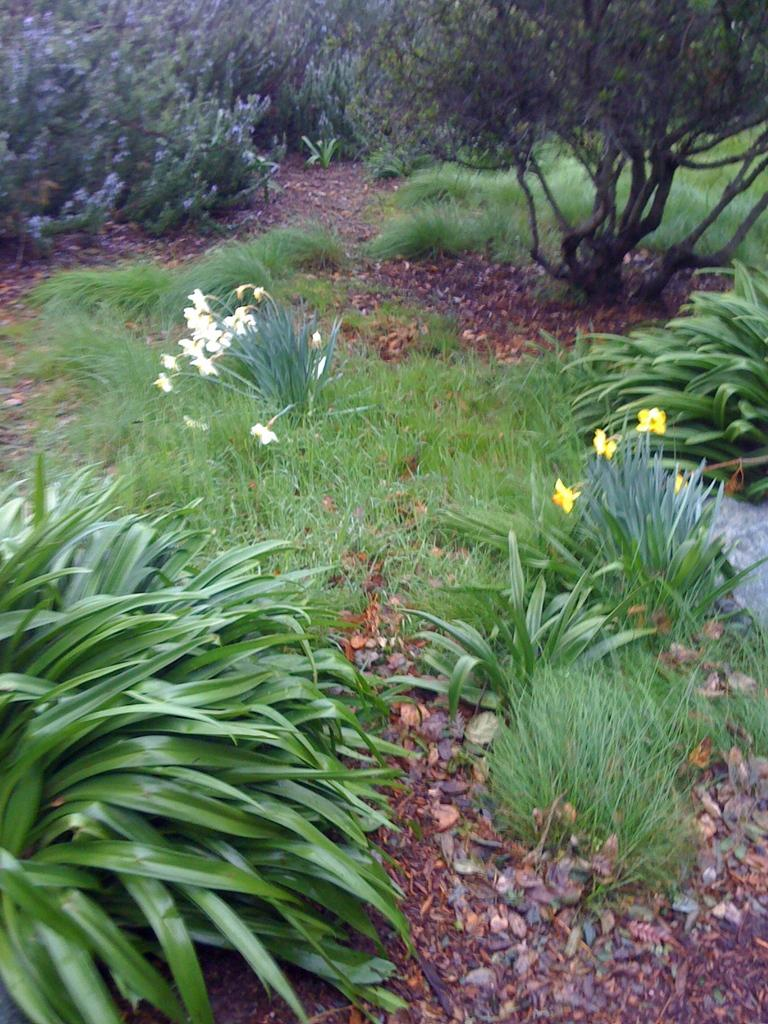What type of vegetation can be seen in the image? There are plants, flowers, and trees visible in the image. What type of ground cover is present in the image? There is grass in the image. What is the primary surface visible in the image? There is ground visible in the image. How many birds are sitting on the sidewalk in the image? There is no sidewalk or birds present in the image. 